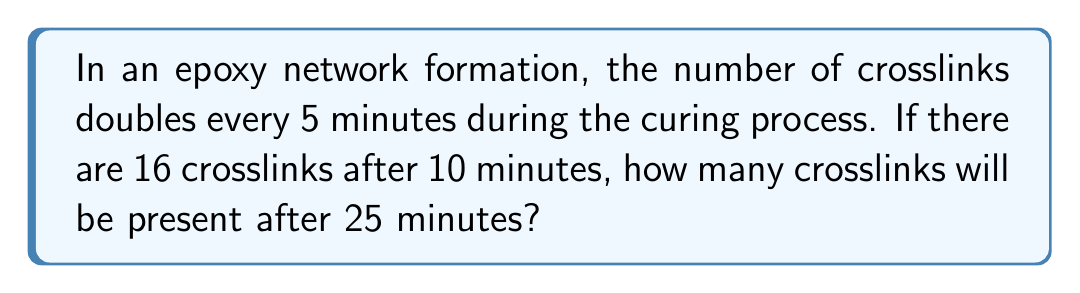Teach me how to tackle this problem. Let's approach this step-by-step:

1) First, we need to identify the initial number of crosslinks and the rate of increase:
   - After 10 minutes, there are 16 crosslinks
   - The number of crosslinks doubles every 5 minutes

2) Let's calculate backwards to find the number of crosslinks at the start (0 minutes):
   - 10 minutes = 2 doubling periods
   - 16 ÷ 2 ÷ 2 = 4 crosslinks at 0 minutes

3) Now, let's calculate forward to 25 minutes:
   - 25 minutes = 5 doubling periods

4) We can express this mathematically as:
   $$ 4 * 2^5 $$

5) Let's calculate:
   $$ 4 * 2^5 = 4 * 32 = 128 $$

Therefore, after 25 minutes, there will be 128 crosslinks in the epoxy network.
Answer: 128 crosslinks 